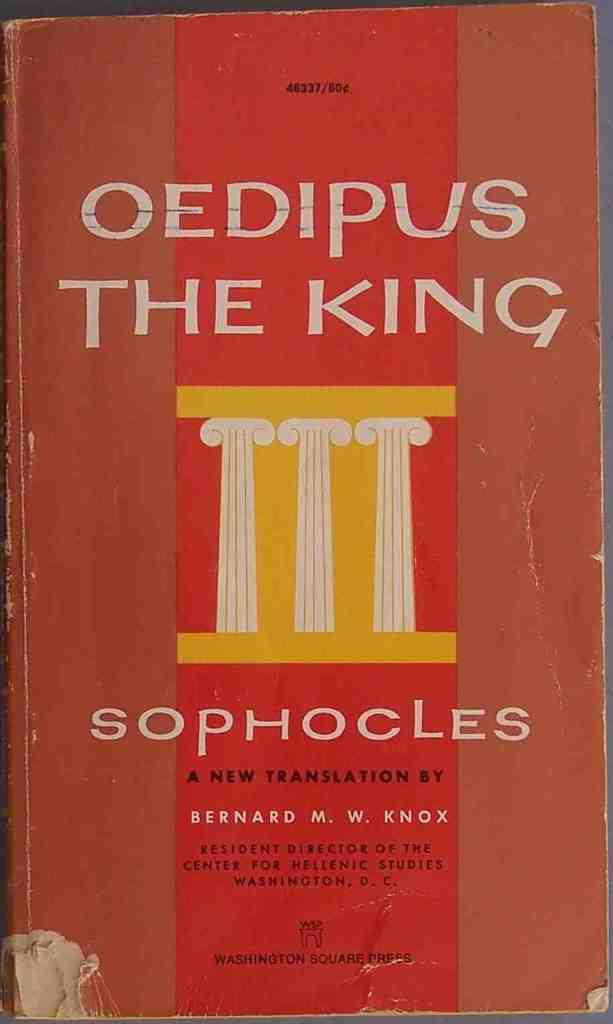Who wrote this?
Your answer should be compact. Sophocles. What is this book's title?
Your answer should be very brief. Oedipus the king. 